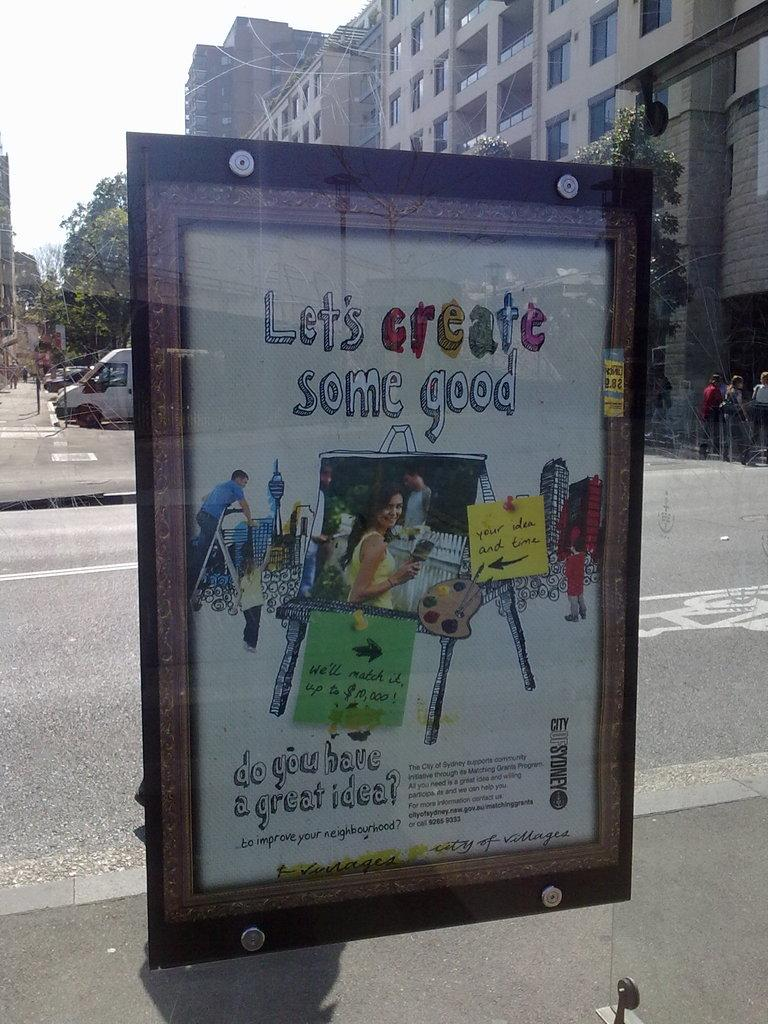<image>
Provide a brief description of the given image. An outdoor poster for Let's create some good. 